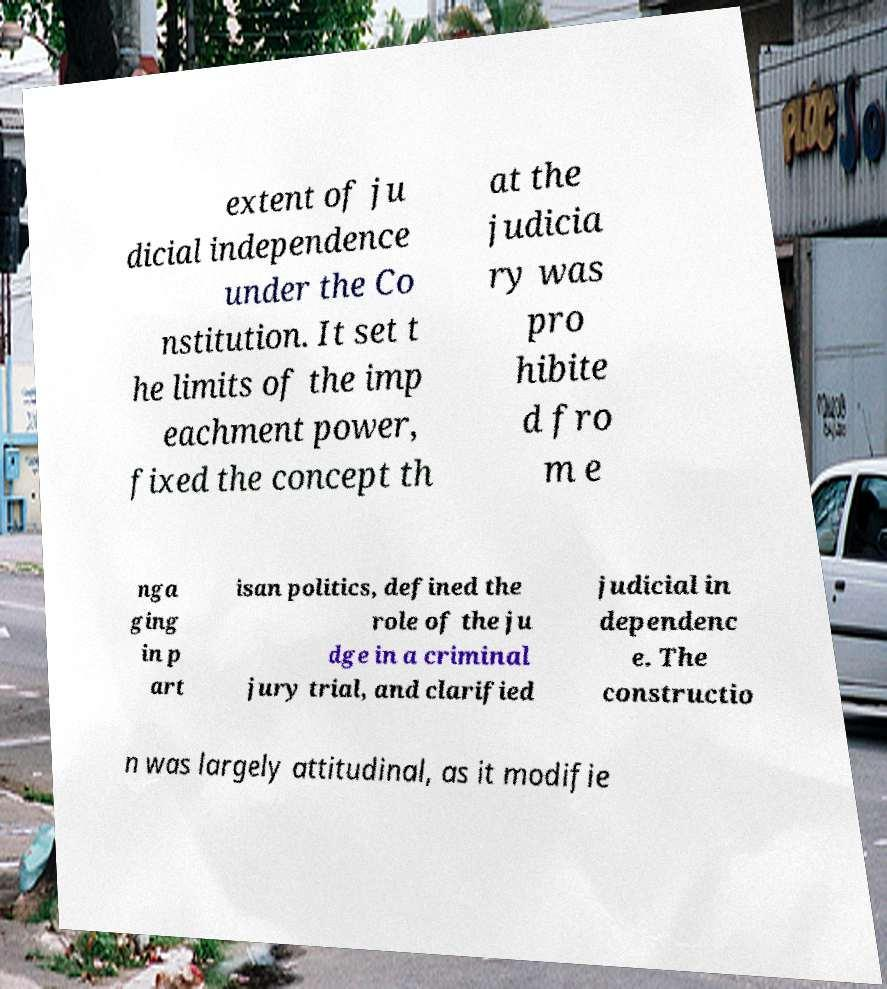For documentation purposes, I need the text within this image transcribed. Could you provide that? extent of ju dicial independence under the Co nstitution. It set t he limits of the imp eachment power, fixed the concept th at the judicia ry was pro hibite d fro m e nga ging in p art isan politics, defined the role of the ju dge in a criminal jury trial, and clarified judicial in dependenc e. The constructio n was largely attitudinal, as it modifie 